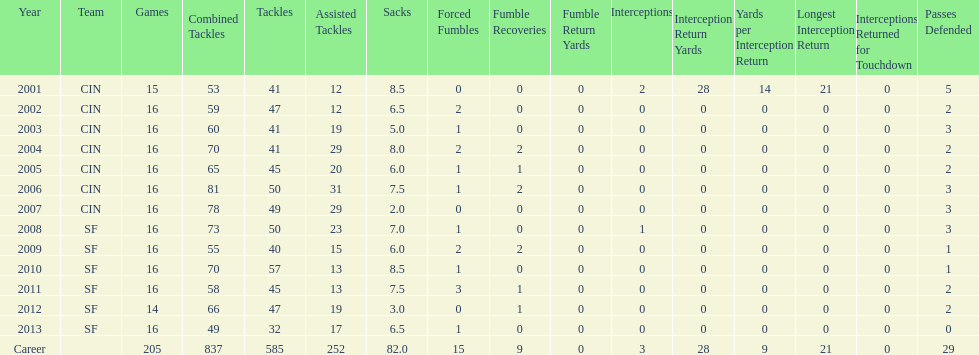Give me the full table as a dictionary. {'header': ['Year', 'Team', 'Games', 'Combined Tackles', 'Tackles', 'Assisted Tackles', 'Sacks', 'Forced Fumbles', 'Fumble Recoveries', 'Fumble Return Yards', 'Interceptions', 'Interception Return Yards', 'Yards per Interception Return', 'Longest Interception Return', 'Interceptions Returned for Touchdown', 'Passes Defended'], 'rows': [['2001', 'CIN', '15', '53', '41', '12', '8.5', '0', '0', '0', '2', '28', '14', '21', '0', '5'], ['2002', 'CIN', '16', '59', '47', '12', '6.5', '2', '0', '0', '0', '0', '0', '0', '0', '2'], ['2003', 'CIN', '16', '60', '41', '19', '5.0', '1', '0', '0', '0', '0', '0', '0', '0', '3'], ['2004', 'CIN', '16', '70', '41', '29', '8.0', '2', '2', '0', '0', '0', '0', '0', '0', '2'], ['2005', 'CIN', '16', '65', '45', '20', '6.0', '1', '1', '0', '0', '0', '0', '0', '0', '2'], ['2006', 'CIN', '16', '81', '50', '31', '7.5', '1', '2', '0', '0', '0', '0', '0', '0', '3'], ['2007', 'CIN', '16', '78', '49', '29', '2.0', '0', '0', '0', '0', '0', '0', '0', '0', '3'], ['2008', 'SF', '16', '73', '50', '23', '7.0', '1', '0', '0', '1', '0', '0', '0', '0', '3'], ['2009', 'SF', '16', '55', '40', '15', '6.0', '2', '2', '0', '0', '0', '0', '0', '0', '1'], ['2010', 'SF', '16', '70', '57', '13', '8.5', '1', '0', '0', '0', '0', '0', '0', '0', '1'], ['2011', 'SF', '16', '58', '45', '13', '7.5', '3', '1', '0', '0', '0', '0', '0', '0', '2'], ['2012', 'SF', '14', '66', '47', '19', '3.0', '0', '1', '0', '0', '0', '0', '0', '0', '2'], ['2013', 'SF', '16', '49', '32', '17', '6.5', '1', '0', '0', '0', '0', '0', '0', '0', '0'], ['Career', '', '205', '837', '585', '252', '82.0', '15', '9', '0', '3', '28', '9', '21', '0', '29']]} In which sole season does he have less than three sacks? 2007. 